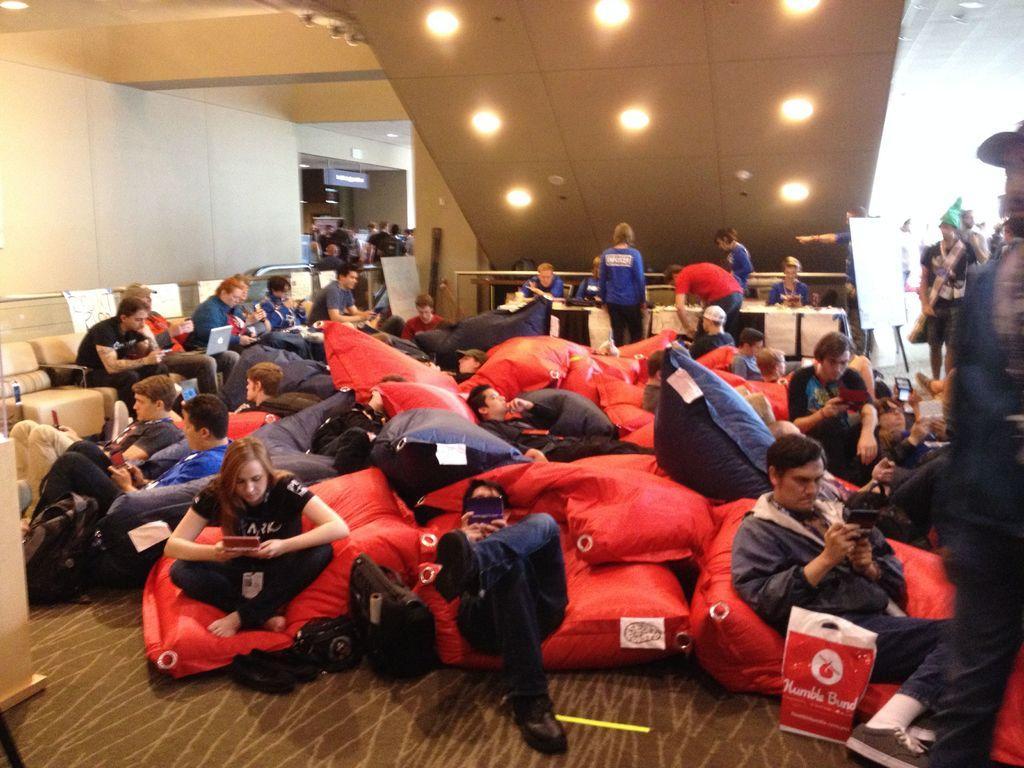How would you summarize this image in a sentence or two? This image is taken indoors. At the bottom of the image there is a floor. At the top of the image there is a ceiling with a few lights. On the left side of the image there is a wall. In the middle of the image many people are sitting on the couches and a few are holding laptops and mobile phones in their hands. There are two tables with tablecloths and a few things on them. A few are standing and there is a board. 